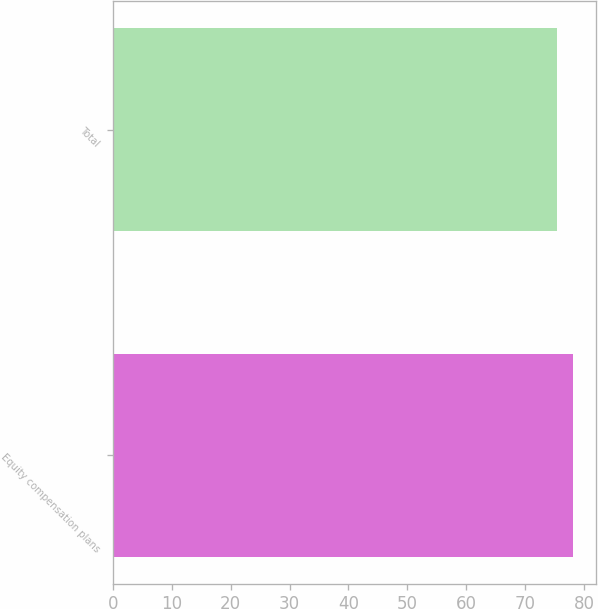Convert chart. <chart><loc_0><loc_0><loc_500><loc_500><bar_chart><fcel>Equity compensation plans<fcel>Total<nl><fcel>78.07<fcel>75.46<nl></chart> 